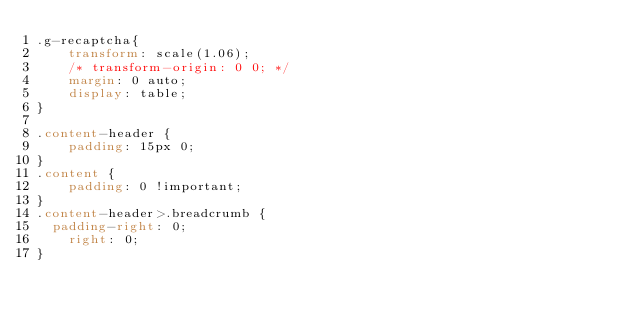<code> <loc_0><loc_0><loc_500><loc_500><_CSS_>.g-recaptcha{
    transform: scale(1.06);
    /* transform-origin: 0 0; */
    margin: 0 auto;
    display: table;
}

.content-header {
    padding: 15px 0;
}
.content {
    padding: 0 !important;
}
.content-header>.breadcrumb {
	padding-right: 0;
    right: 0;
}</code> 